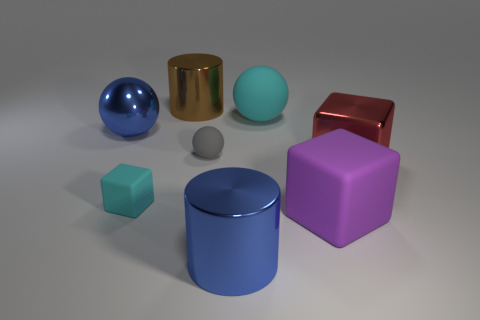Add 1 big brown metal cylinders. How many objects exist? 9 Subtract all brown cylinders. How many cylinders are left? 1 Subtract all cyan balls. How many balls are left? 2 Subtract all balls. How many objects are left? 5 Subtract all purple cylinders. Subtract all yellow spheres. How many cylinders are left? 2 Subtract all cyan cubes. How many blue spheres are left? 1 Subtract 1 cylinders. How many cylinders are left? 1 Subtract all big rubber spheres. Subtract all red cubes. How many objects are left? 6 Add 5 large cyan rubber balls. How many large cyan rubber balls are left? 6 Add 8 red blocks. How many red blocks exist? 9 